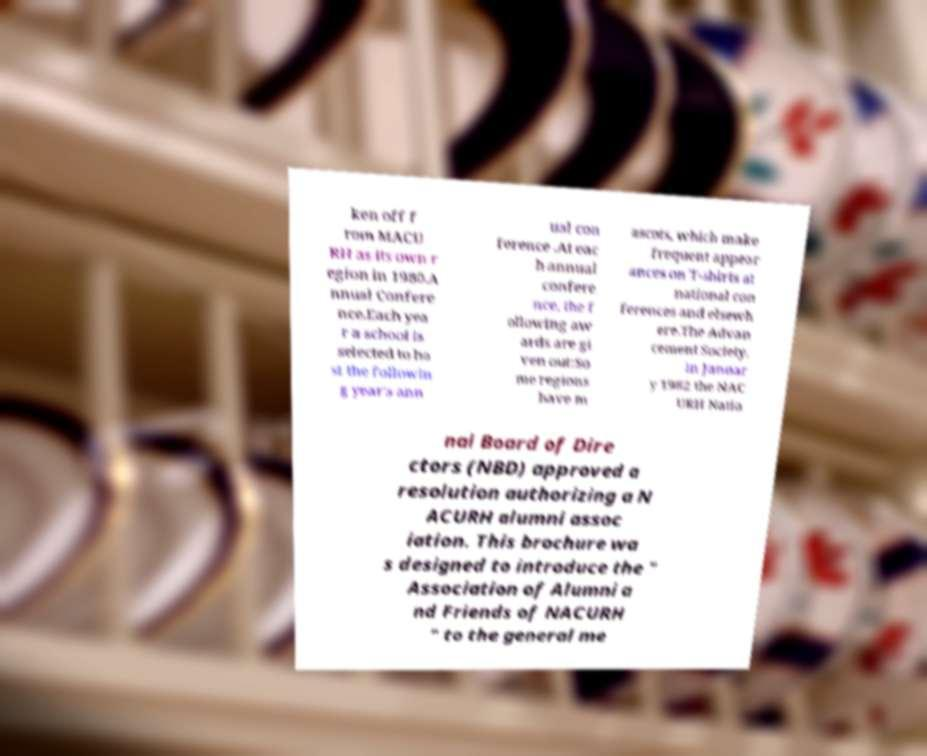Could you extract and type out the text from this image? ken off f rom MACU RH as its own r egion in 1980.A nnual Confere nce.Each yea r a school is selected to ho st the followin g year's ann ual con ference .At eac h annual confere nce, the f ollowing aw ards are gi ven out:So me regions have m ascots, which make frequent appear ances on T-shirts at national con ferences and elsewh ere.The Advan cement Society. In Januar y 1982 the NAC URH Natio nal Board of Dire ctors (NBD) approved a resolution authorizing a N ACURH alumni assoc iation. This brochure wa s designed to introduce the " Association of Alumni a nd Friends of NACURH " to the general me 